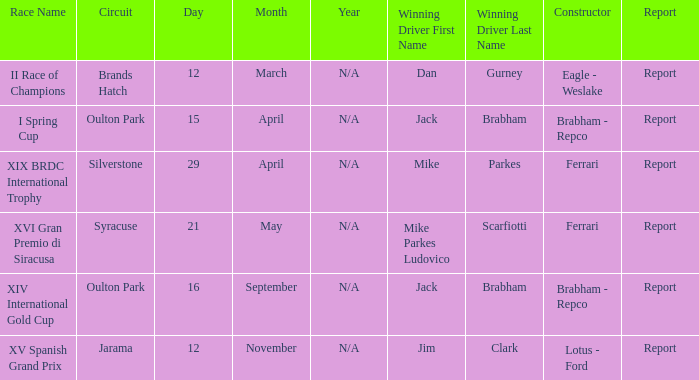What company constrcuted the vehicle with a circuit of oulton park on 15 april? Brabham - Repco. Could you parse the entire table? {'header': ['Race Name', 'Circuit', 'Day', 'Month', 'Year', 'Winning Driver First Name', 'Winning Driver Last Name', 'Constructor', 'Report'], 'rows': [['II Race of Champions', 'Brands Hatch', '12', 'March', 'N/A', 'Dan', 'Gurney', 'Eagle - Weslake', 'Report'], ['I Spring Cup', 'Oulton Park', '15', 'April', 'N/A', 'Jack', 'Brabham', 'Brabham - Repco', 'Report'], ['XIX BRDC International Trophy', 'Silverstone', '29', 'April', 'N/A', 'Mike', 'Parkes', 'Ferrari', 'Report'], ['XVI Gran Premio di Siracusa', 'Syracuse', '21', 'May', 'N/A', 'Mike Parkes Ludovico', 'Scarfiotti', 'Ferrari', 'Report'], ['XIV International Gold Cup', 'Oulton Park', '16', 'September', 'N/A', 'Jack', 'Brabham', 'Brabham - Repco', 'Report'], ['XV Spanish Grand Prix', 'Jarama', '12', 'November', 'N/A', 'Jim', 'Clark', 'Lotus - Ford', 'Report']]} 